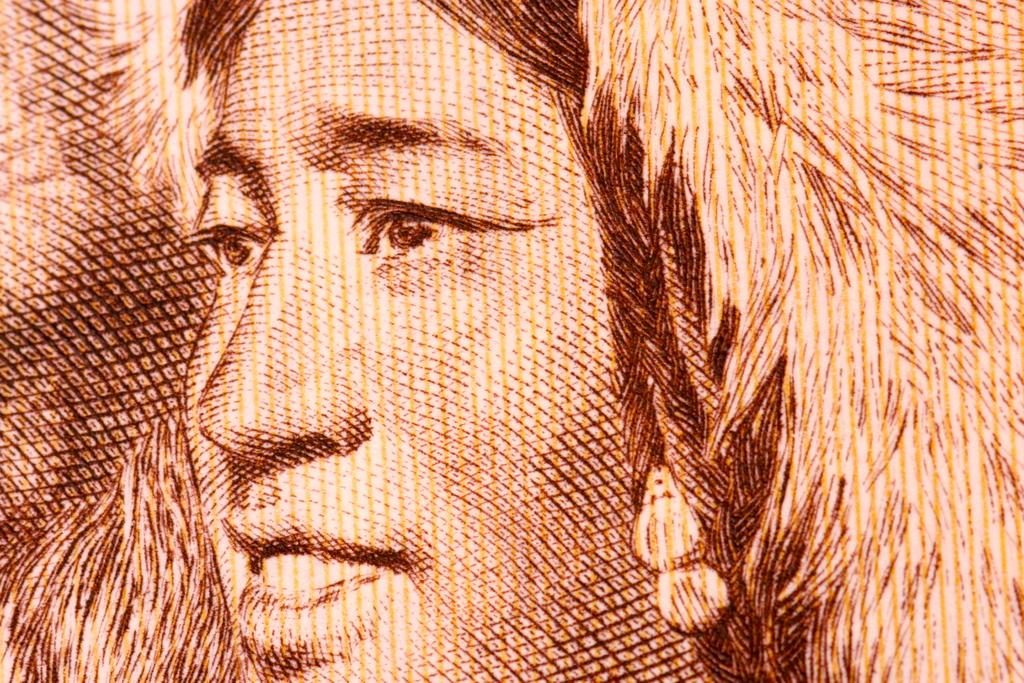What is the main subject in the foreground of the image? There is a face of a person in the foreground of the image. What type of tax is being discussed in the image? There is no mention of tax or any discussion in the image; it only features the face of a person. 